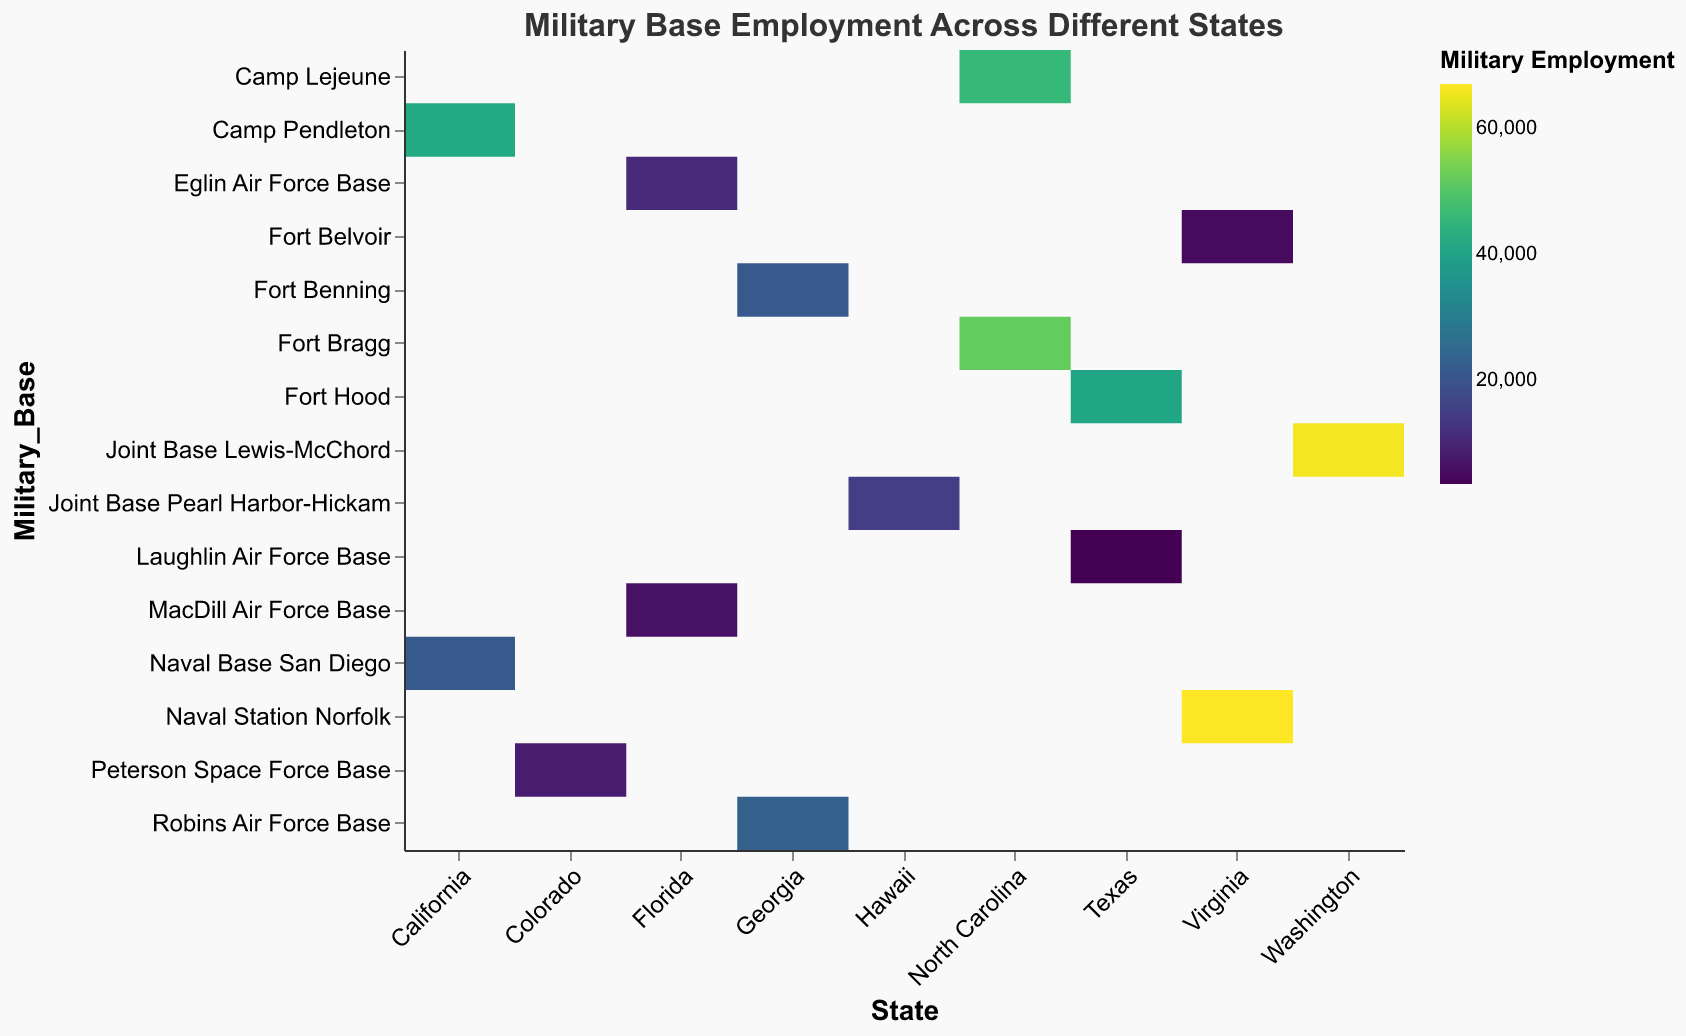What is the title of the heatmap? The title can be seen at the top of the heatmap, which provides a summary of the visualized data.
Answer: Military Base Employment Across Different States How many military bases are there in Virginia? Locate the "Virginia" column and count the number of entries for different military bases.
Answer: 2 Which military base has the highest employment? Identify the base with the darkest color within its respective row, indicating the highest value on the scale.
Answer: Naval Station Norfolk What is the total military employment for all bases in California? Sum the employment figures for Camp Pendleton and Naval Base San Diego. 42,000 + 21,000 = 63,000
Answer: 63,000 Which state has the most military bases listed in the heatmap? Count the number of different entries (military bases) per state column and find the highest count.
Answer: California Is the employment at Fort Hood greater than at Joint Base Pearl Harbor-Hickam? Compare the employment numbers: Fort Hood has 41,000, and Joint Base Pearl Harbor-Hickam has 15,000, so 41,000 > 15,000.
Answer: Yes Which state has the highest cumulative military employment? Sum the military employment for each state and compare the totals: Virginia (67,000 + 5,100 = 72,100), North Carolina (52,000 + 46,000 = 98,000), etc.
Answer: North Carolina What is the average military employment per base in Florida? Add the employment figures for Eglin Air Force Base and MacDill Air Force Base, then divide by the number of bases: (11,200 + 6,300) / 2 = 8,750
Answer: 8,750 Between Fort Bragg and Camp Lejeune, which base has a lower employment figure? Compare the employment figures: Fort Bragg has 52,000, and Camp Lejeune has 46,000.
Answer: Camp Lejeune What is the color scheme used to represent military employment in the heatmap? Identify the color gradient described in the legend and encoding section.
Answer: Viridis 